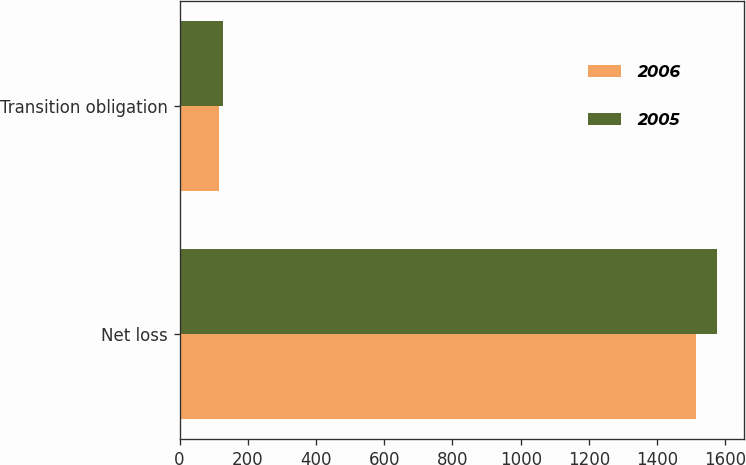Convert chart. <chart><loc_0><loc_0><loc_500><loc_500><stacked_bar_chart><ecel><fcel>Net loss<fcel>Transition obligation<nl><fcel>2006<fcel>1514<fcel>117<nl><fcel>2005<fcel>1576<fcel>126<nl></chart> 